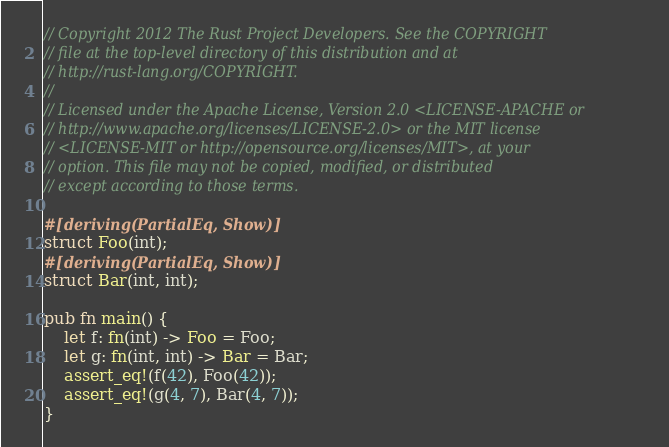Convert code to text. <code><loc_0><loc_0><loc_500><loc_500><_Rust_>// Copyright 2012 The Rust Project Developers. See the COPYRIGHT
// file at the top-level directory of this distribution and at
// http://rust-lang.org/COPYRIGHT.
//
// Licensed under the Apache License, Version 2.0 <LICENSE-APACHE or
// http://www.apache.org/licenses/LICENSE-2.0> or the MIT license
// <LICENSE-MIT or http://opensource.org/licenses/MIT>, at your
// option. This file may not be copied, modified, or distributed
// except according to those terms.

#[deriving(PartialEq, Show)]
struct Foo(int);
#[deriving(PartialEq, Show)]
struct Bar(int, int);

pub fn main() {
    let f: fn(int) -> Foo = Foo;
    let g: fn(int, int) -> Bar = Bar;
    assert_eq!(f(42), Foo(42));
    assert_eq!(g(4, 7), Bar(4, 7));
}
</code> 